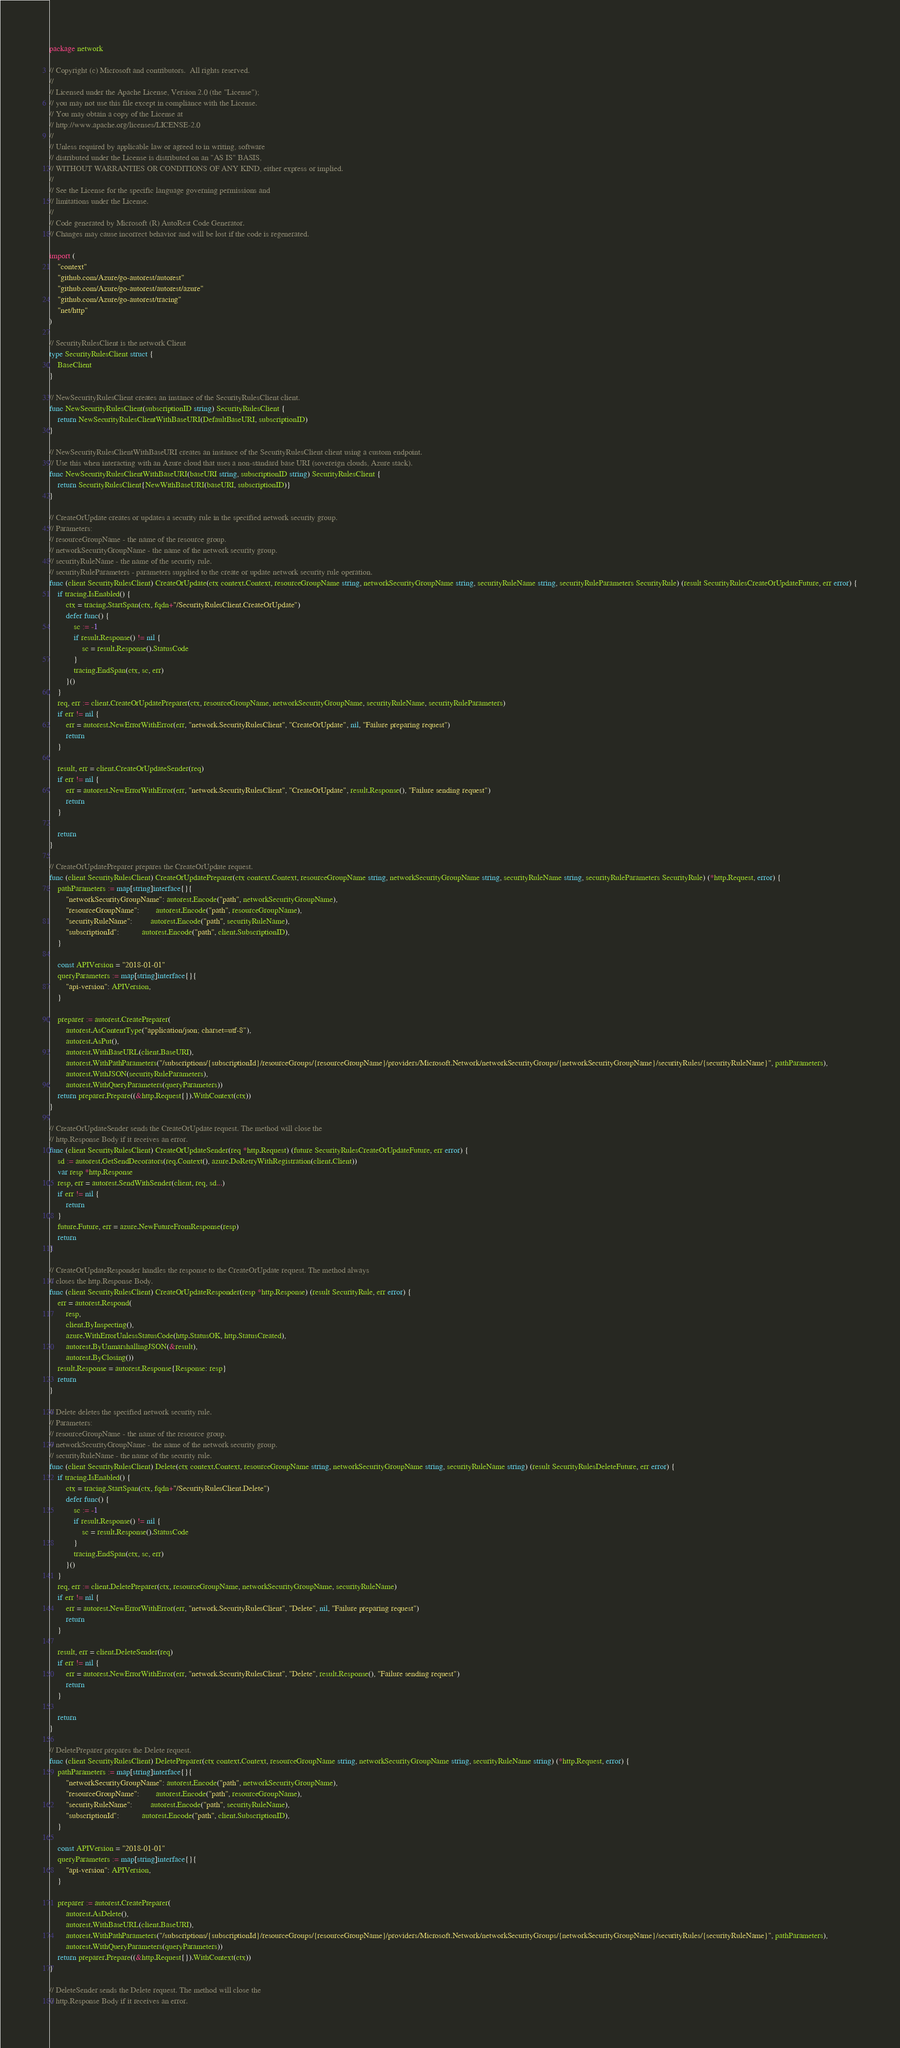<code> <loc_0><loc_0><loc_500><loc_500><_Go_>package network

// Copyright (c) Microsoft and contributors.  All rights reserved.
//
// Licensed under the Apache License, Version 2.0 (the "License");
// you may not use this file except in compliance with the License.
// You may obtain a copy of the License at
// http://www.apache.org/licenses/LICENSE-2.0
//
// Unless required by applicable law or agreed to in writing, software
// distributed under the License is distributed on an "AS IS" BASIS,
// WITHOUT WARRANTIES OR CONDITIONS OF ANY KIND, either express or implied.
//
// See the License for the specific language governing permissions and
// limitations under the License.
//
// Code generated by Microsoft (R) AutoRest Code Generator.
// Changes may cause incorrect behavior and will be lost if the code is regenerated.

import (
	"context"
	"github.com/Azure/go-autorest/autorest"
	"github.com/Azure/go-autorest/autorest/azure"
	"github.com/Azure/go-autorest/tracing"
	"net/http"
)

// SecurityRulesClient is the network Client
type SecurityRulesClient struct {
	BaseClient
}

// NewSecurityRulesClient creates an instance of the SecurityRulesClient client.
func NewSecurityRulesClient(subscriptionID string) SecurityRulesClient {
	return NewSecurityRulesClientWithBaseURI(DefaultBaseURI, subscriptionID)
}

// NewSecurityRulesClientWithBaseURI creates an instance of the SecurityRulesClient client using a custom endpoint.
// Use this when interacting with an Azure cloud that uses a non-standard base URI (sovereign clouds, Azure stack).
func NewSecurityRulesClientWithBaseURI(baseURI string, subscriptionID string) SecurityRulesClient {
	return SecurityRulesClient{NewWithBaseURI(baseURI, subscriptionID)}
}

// CreateOrUpdate creates or updates a security rule in the specified network security group.
// Parameters:
// resourceGroupName - the name of the resource group.
// networkSecurityGroupName - the name of the network security group.
// securityRuleName - the name of the security rule.
// securityRuleParameters - parameters supplied to the create or update network security rule operation.
func (client SecurityRulesClient) CreateOrUpdate(ctx context.Context, resourceGroupName string, networkSecurityGroupName string, securityRuleName string, securityRuleParameters SecurityRule) (result SecurityRulesCreateOrUpdateFuture, err error) {
	if tracing.IsEnabled() {
		ctx = tracing.StartSpan(ctx, fqdn+"/SecurityRulesClient.CreateOrUpdate")
		defer func() {
			sc := -1
			if result.Response() != nil {
				sc = result.Response().StatusCode
			}
			tracing.EndSpan(ctx, sc, err)
		}()
	}
	req, err := client.CreateOrUpdatePreparer(ctx, resourceGroupName, networkSecurityGroupName, securityRuleName, securityRuleParameters)
	if err != nil {
		err = autorest.NewErrorWithError(err, "network.SecurityRulesClient", "CreateOrUpdate", nil, "Failure preparing request")
		return
	}

	result, err = client.CreateOrUpdateSender(req)
	if err != nil {
		err = autorest.NewErrorWithError(err, "network.SecurityRulesClient", "CreateOrUpdate", result.Response(), "Failure sending request")
		return
	}

	return
}

// CreateOrUpdatePreparer prepares the CreateOrUpdate request.
func (client SecurityRulesClient) CreateOrUpdatePreparer(ctx context.Context, resourceGroupName string, networkSecurityGroupName string, securityRuleName string, securityRuleParameters SecurityRule) (*http.Request, error) {
	pathParameters := map[string]interface{}{
		"networkSecurityGroupName": autorest.Encode("path", networkSecurityGroupName),
		"resourceGroupName":        autorest.Encode("path", resourceGroupName),
		"securityRuleName":         autorest.Encode("path", securityRuleName),
		"subscriptionId":           autorest.Encode("path", client.SubscriptionID),
	}

	const APIVersion = "2018-01-01"
	queryParameters := map[string]interface{}{
		"api-version": APIVersion,
	}

	preparer := autorest.CreatePreparer(
		autorest.AsContentType("application/json; charset=utf-8"),
		autorest.AsPut(),
		autorest.WithBaseURL(client.BaseURI),
		autorest.WithPathParameters("/subscriptions/{subscriptionId}/resourceGroups/{resourceGroupName}/providers/Microsoft.Network/networkSecurityGroups/{networkSecurityGroupName}/securityRules/{securityRuleName}", pathParameters),
		autorest.WithJSON(securityRuleParameters),
		autorest.WithQueryParameters(queryParameters))
	return preparer.Prepare((&http.Request{}).WithContext(ctx))
}

// CreateOrUpdateSender sends the CreateOrUpdate request. The method will close the
// http.Response Body if it receives an error.
func (client SecurityRulesClient) CreateOrUpdateSender(req *http.Request) (future SecurityRulesCreateOrUpdateFuture, err error) {
	sd := autorest.GetSendDecorators(req.Context(), azure.DoRetryWithRegistration(client.Client))
	var resp *http.Response
	resp, err = autorest.SendWithSender(client, req, sd...)
	if err != nil {
		return
	}
	future.Future, err = azure.NewFutureFromResponse(resp)
	return
}

// CreateOrUpdateResponder handles the response to the CreateOrUpdate request. The method always
// closes the http.Response Body.
func (client SecurityRulesClient) CreateOrUpdateResponder(resp *http.Response) (result SecurityRule, err error) {
	err = autorest.Respond(
		resp,
		client.ByInspecting(),
		azure.WithErrorUnlessStatusCode(http.StatusOK, http.StatusCreated),
		autorest.ByUnmarshallingJSON(&result),
		autorest.ByClosing())
	result.Response = autorest.Response{Response: resp}
	return
}

// Delete deletes the specified network security rule.
// Parameters:
// resourceGroupName - the name of the resource group.
// networkSecurityGroupName - the name of the network security group.
// securityRuleName - the name of the security rule.
func (client SecurityRulesClient) Delete(ctx context.Context, resourceGroupName string, networkSecurityGroupName string, securityRuleName string) (result SecurityRulesDeleteFuture, err error) {
	if tracing.IsEnabled() {
		ctx = tracing.StartSpan(ctx, fqdn+"/SecurityRulesClient.Delete")
		defer func() {
			sc := -1
			if result.Response() != nil {
				sc = result.Response().StatusCode
			}
			tracing.EndSpan(ctx, sc, err)
		}()
	}
	req, err := client.DeletePreparer(ctx, resourceGroupName, networkSecurityGroupName, securityRuleName)
	if err != nil {
		err = autorest.NewErrorWithError(err, "network.SecurityRulesClient", "Delete", nil, "Failure preparing request")
		return
	}

	result, err = client.DeleteSender(req)
	if err != nil {
		err = autorest.NewErrorWithError(err, "network.SecurityRulesClient", "Delete", result.Response(), "Failure sending request")
		return
	}

	return
}

// DeletePreparer prepares the Delete request.
func (client SecurityRulesClient) DeletePreparer(ctx context.Context, resourceGroupName string, networkSecurityGroupName string, securityRuleName string) (*http.Request, error) {
	pathParameters := map[string]interface{}{
		"networkSecurityGroupName": autorest.Encode("path", networkSecurityGroupName),
		"resourceGroupName":        autorest.Encode("path", resourceGroupName),
		"securityRuleName":         autorest.Encode("path", securityRuleName),
		"subscriptionId":           autorest.Encode("path", client.SubscriptionID),
	}

	const APIVersion = "2018-01-01"
	queryParameters := map[string]interface{}{
		"api-version": APIVersion,
	}

	preparer := autorest.CreatePreparer(
		autorest.AsDelete(),
		autorest.WithBaseURL(client.BaseURI),
		autorest.WithPathParameters("/subscriptions/{subscriptionId}/resourceGroups/{resourceGroupName}/providers/Microsoft.Network/networkSecurityGroups/{networkSecurityGroupName}/securityRules/{securityRuleName}", pathParameters),
		autorest.WithQueryParameters(queryParameters))
	return preparer.Prepare((&http.Request{}).WithContext(ctx))
}

// DeleteSender sends the Delete request. The method will close the
// http.Response Body if it receives an error.</code> 